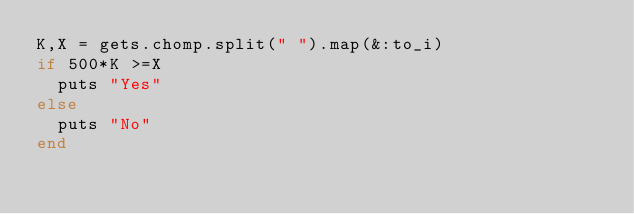Convert code to text. <code><loc_0><loc_0><loc_500><loc_500><_Ruby_>K,X = gets.chomp.split(" ").map(&:to_i)
if 500*K >=X
  puts "Yes"
else
  puts "No"
end
</code> 